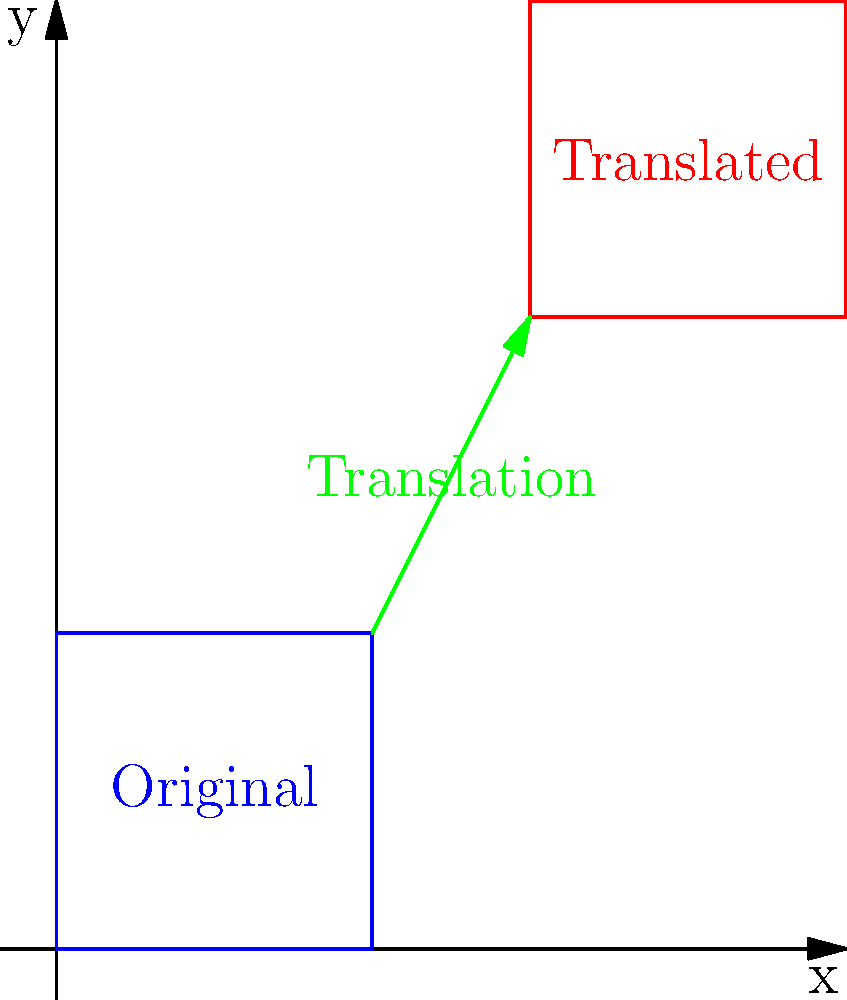Consider the album cover artwork for Asking Alexandria's "Stand Up and Scream" represented by a $2 \times 2$ square on a coordinate plane. If the original position of the album cover has its bottom-left corner at $(0,0)$ and its top-right corner at $(2,2)$, what is the position vector of the translation that moves the album cover to its new position with the bottom-left corner at $(3,4)$? To find the position vector of the translation, we need to follow these steps:

1) Identify the original position:
   Bottom-left corner: $(0,0)$
   Top-right corner: $(2,2)$

2) Identify the new position:
   Bottom-left corner: $(3,4)$
   (We don't need the top-right corner for this calculation)

3) Calculate the translation vector:
   The translation vector is the difference between the new position and the original position of a reference point (in this case, the bottom-left corner).

   Translation vector = New position - Original position
                      = $(3,4) - (0,0)$
                      = $(3-0, 4-0)$
                      = $(3,4)$

Therefore, the position vector of the translation is $\langle 3,4 \rangle$ or $(3,4)$.
Answer: $\langle 3,4 \rangle$ 